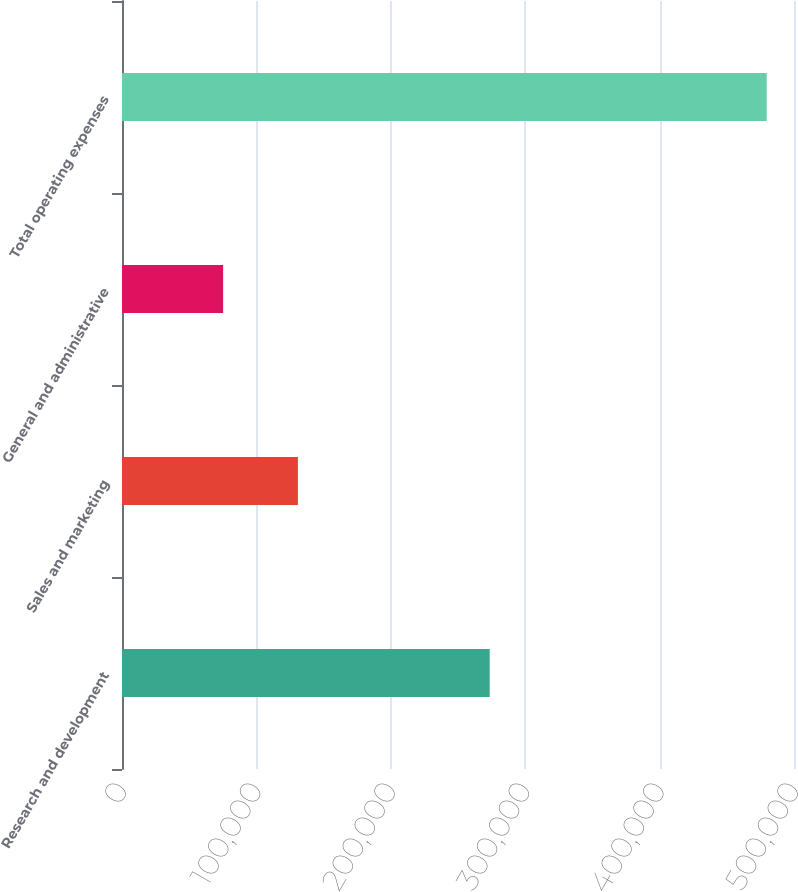Convert chart to OTSL. <chart><loc_0><loc_0><loc_500><loc_500><bar_chart><fcel>Research and development<fcel>Sales and marketing<fcel>General and administrative<fcel>Total operating expenses<nl><fcel>273581<fcel>130887<fcel>75239<fcel>479707<nl></chart> 